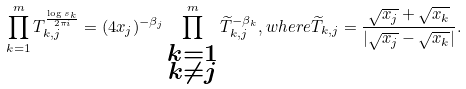Convert formula to latex. <formula><loc_0><loc_0><loc_500><loc_500>\prod _ { k = 1 } ^ { m } T _ { k , j } ^ { \frac { \log s _ { k } } { 2 \pi i } } = ( 4 x _ { j } ) ^ { - \beta _ { j } } \prod _ { \substack { k = 1 \\ k \neq j } } ^ { m } \widetilde { T } _ { k , j } ^ { - \beta _ { k } } , w h e r e \widetilde { T } _ { k , j } = \frac { \sqrt { x _ { j } } + \sqrt { x _ { k } } } { | \sqrt { x _ { j } } - \sqrt { x _ { k } } | } .</formula> 